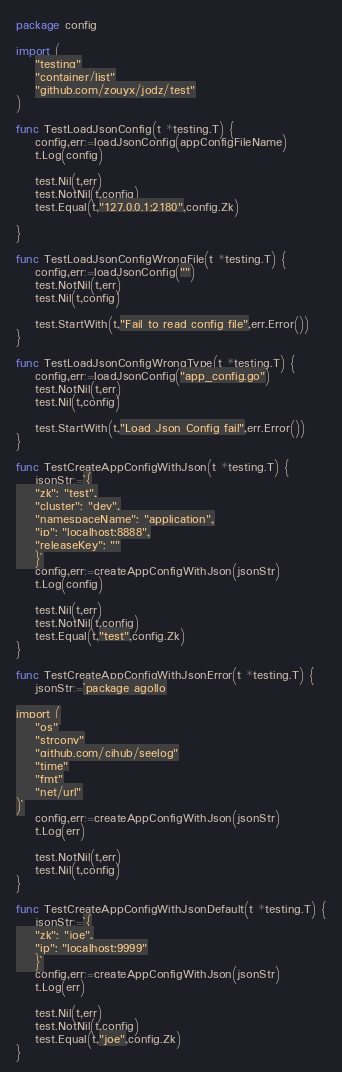<code> <loc_0><loc_0><loc_500><loc_500><_Go_>package config

import (
	"testing"
	"container/list"
	"github.com/zouyx/jodz/test"
)

func TestLoadJsonConfig(t *testing.T) {
	config,err:=loadJsonConfig(appConfigFileName)
	t.Log(config)

	test.Nil(t,err)
	test.NotNil(t,config)
	test.Equal(t,"127.0.0.1:2180",config.Zk)

}

func TestLoadJsonConfigWrongFile(t *testing.T) {
	config,err:=loadJsonConfig("")
	test.NotNil(t,err)
	test.Nil(t,config)

	test.StartWith(t,"Fail to read config file",err.Error())
}

func TestLoadJsonConfigWrongType(t *testing.T) {
	config,err:=loadJsonConfig("app_config.go")
	test.NotNil(t,err)
	test.Nil(t,config)

	test.StartWith(t,"Load Json Config fail",err.Error())
}

func TestCreateAppConfigWithJson(t *testing.T) {
	jsonStr:=`{
    "zk": "test",
    "cluster": "dev",
    "namespaceName": "application",
    "ip": "localhost:8888",
    "releaseKey": ""
	}`
	config,err:=createAppConfigWithJson(jsonStr)
	t.Log(config)

	test.Nil(t,err)
	test.NotNil(t,config)
	test.Equal(t,"test",config.Zk)
}

func TestCreateAppConfigWithJsonError(t *testing.T) {
	jsonStr:=`package agollo

import (
	"os"
	"strconv"
	"github.com/cihub/seelog"
	"time"
	"fmt"
	"net/url"
)`
	config,err:=createAppConfigWithJson(jsonStr)
	t.Log(err)

	test.NotNil(t,err)
	test.Nil(t,config)
}

func TestCreateAppConfigWithJsonDefault(t *testing.T) {
	jsonStr:=`{
    "zk": "joe",
    "ip": "localhost:9999"
	}`
	config,err:=createAppConfigWithJson(jsonStr)
	t.Log(err)

	test.Nil(t,err)
	test.NotNil(t,config)
	test.Equal(t,"joe",config.Zk)
}
</code> 